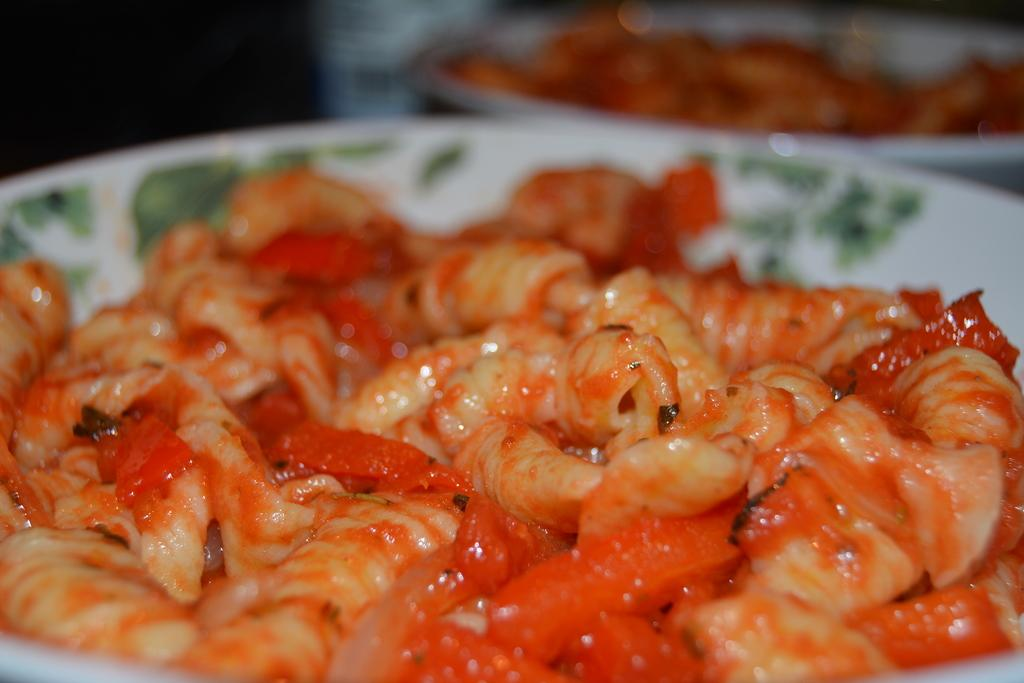What is on the plates that are visible in the image? There are plates with food in the image. What colors are the plates in the image? The plates are in white and green color. What colors are the food on the plates? The food is in cream and red color. Can you describe the background of the image? The background of the image is blurred. How does the food on the plates prepare for a voyage in the image? The food on the plates does not prepare for a voyage in the image; it is stationary on the plates. 